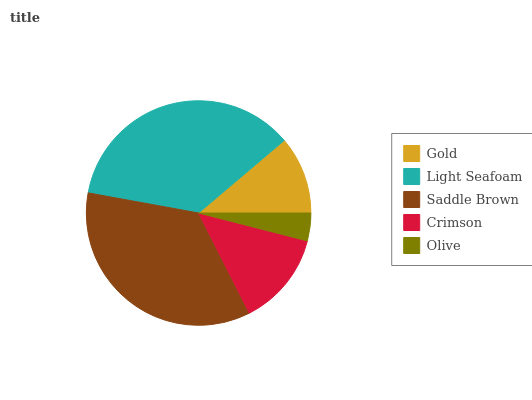Is Olive the minimum?
Answer yes or no. Yes. Is Light Seafoam the maximum?
Answer yes or no. Yes. Is Saddle Brown the minimum?
Answer yes or no. No. Is Saddle Brown the maximum?
Answer yes or no. No. Is Light Seafoam greater than Saddle Brown?
Answer yes or no. Yes. Is Saddle Brown less than Light Seafoam?
Answer yes or no. Yes. Is Saddle Brown greater than Light Seafoam?
Answer yes or no. No. Is Light Seafoam less than Saddle Brown?
Answer yes or no. No. Is Crimson the high median?
Answer yes or no. Yes. Is Crimson the low median?
Answer yes or no. Yes. Is Saddle Brown the high median?
Answer yes or no. No. Is Olive the low median?
Answer yes or no. No. 